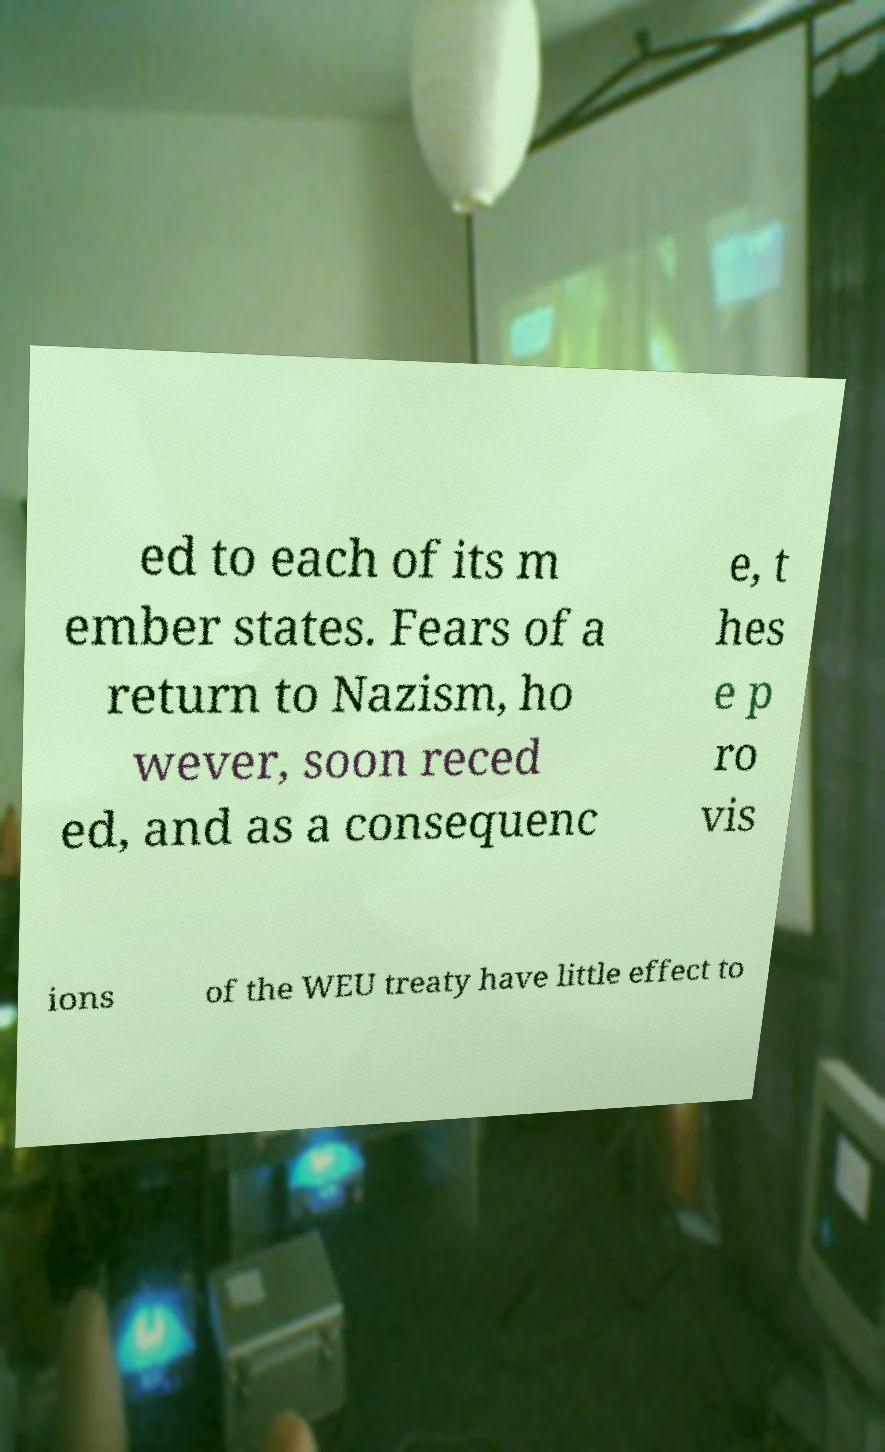Can you read and provide the text displayed in the image?This photo seems to have some interesting text. Can you extract and type it out for me? ed to each of its m ember states. Fears of a return to Nazism, ho wever, soon reced ed, and as a consequenc e, t hes e p ro vis ions of the WEU treaty have little effect to 